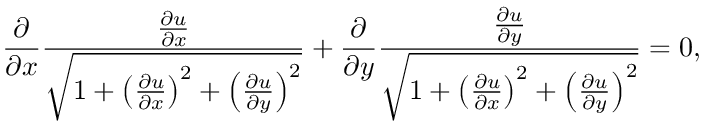Convert formula to latex. <formula><loc_0><loc_0><loc_500><loc_500>{ \frac { \partial } { \partial x } } { \frac { \frac { \partial u } { \partial x } } { \sqrt { 1 + \left ( { \frac { \partial u } { \partial x } } \right ) ^ { 2 } + \left ( { \frac { \partial u } { \partial y } } \right ) ^ { 2 } } } } + { \frac { \partial } { \partial y } } { \frac { \frac { \partial u } { \partial y } } { \sqrt { 1 + \left ( { \frac { \partial u } { \partial x } } \right ) ^ { 2 } + \left ( { \frac { \partial u } { \partial y } } \right ) ^ { 2 } } } } = 0 ,</formula> 